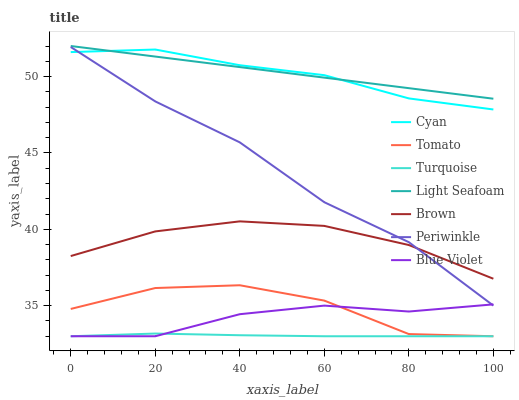Does Turquoise have the minimum area under the curve?
Answer yes or no. Yes. Does Light Seafoam have the maximum area under the curve?
Answer yes or no. Yes. Does Brown have the minimum area under the curve?
Answer yes or no. No. Does Brown have the maximum area under the curve?
Answer yes or no. No. Is Light Seafoam the smoothest?
Answer yes or no. Yes. Is Tomato the roughest?
Answer yes or no. Yes. Is Brown the smoothest?
Answer yes or no. No. Is Brown the roughest?
Answer yes or no. No. Does Brown have the lowest value?
Answer yes or no. No. Does Brown have the highest value?
Answer yes or no. No. Is Blue Violet less than Light Seafoam?
Answer yes or no. Yes. Is Periwinkle greater than Turquoise?
Answer yes or no. Yes. Does Blue Violet intersect Light Seafoam?
Answer yes or no. No. 